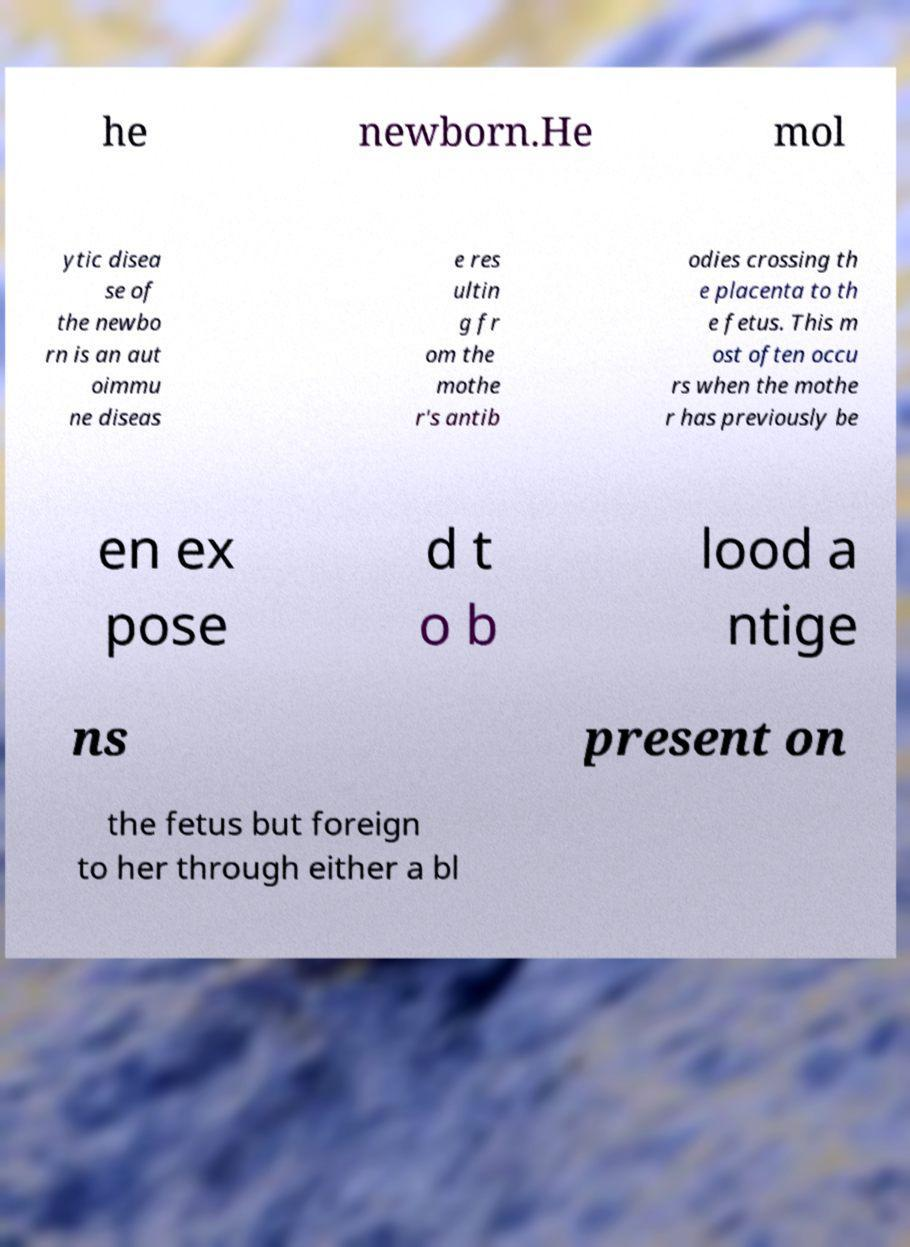There's text embedded in this image that I need extracted. Can you transcribe it verbatim? he newborn.He mol ytic disea se of the newbo rn is an aut oimmu ne diseas e res ultin g fr om the mothe r's antib odies crossing th e placenta to th e fetus. This m ost often occu rs when the mothe r has previously be en ex pose d t o b lood a ntige ns present on the fetus but foreign to her through either a bl 